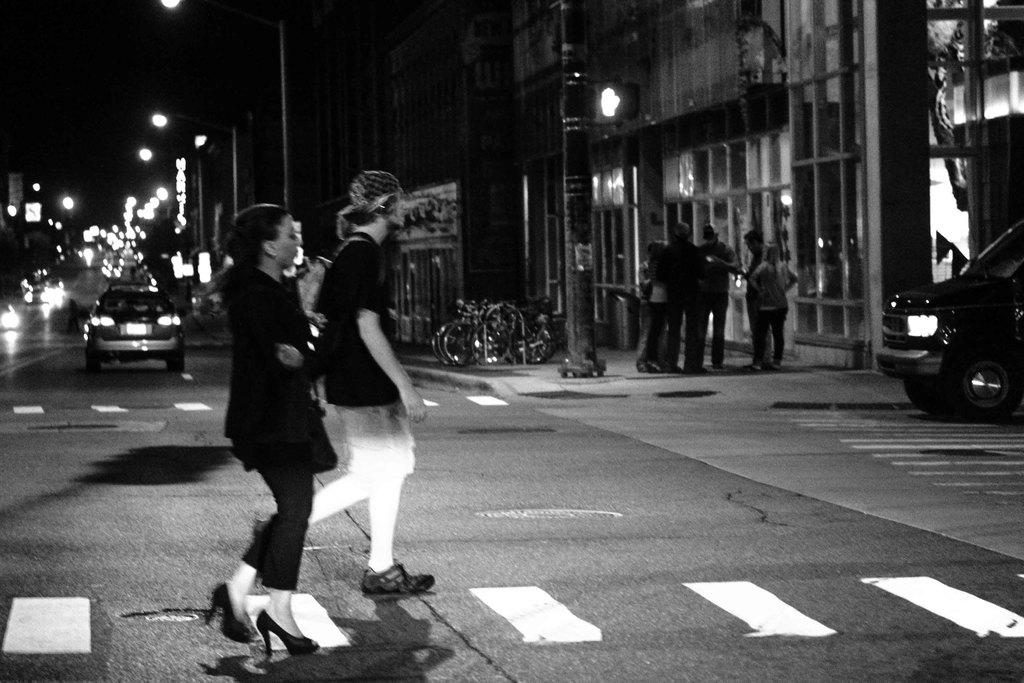Who or what can be seen in the image? There are people in the image. What else is present in the image besides people? There are vehicles on the road in the image. Are there any other notable features in the image? Yes, there are lights visible in the image. What is the color scheme of the image? The image is in black and white color. Can you see a frog hopping down the alley in the image? There is no alley or frog present in the image. 